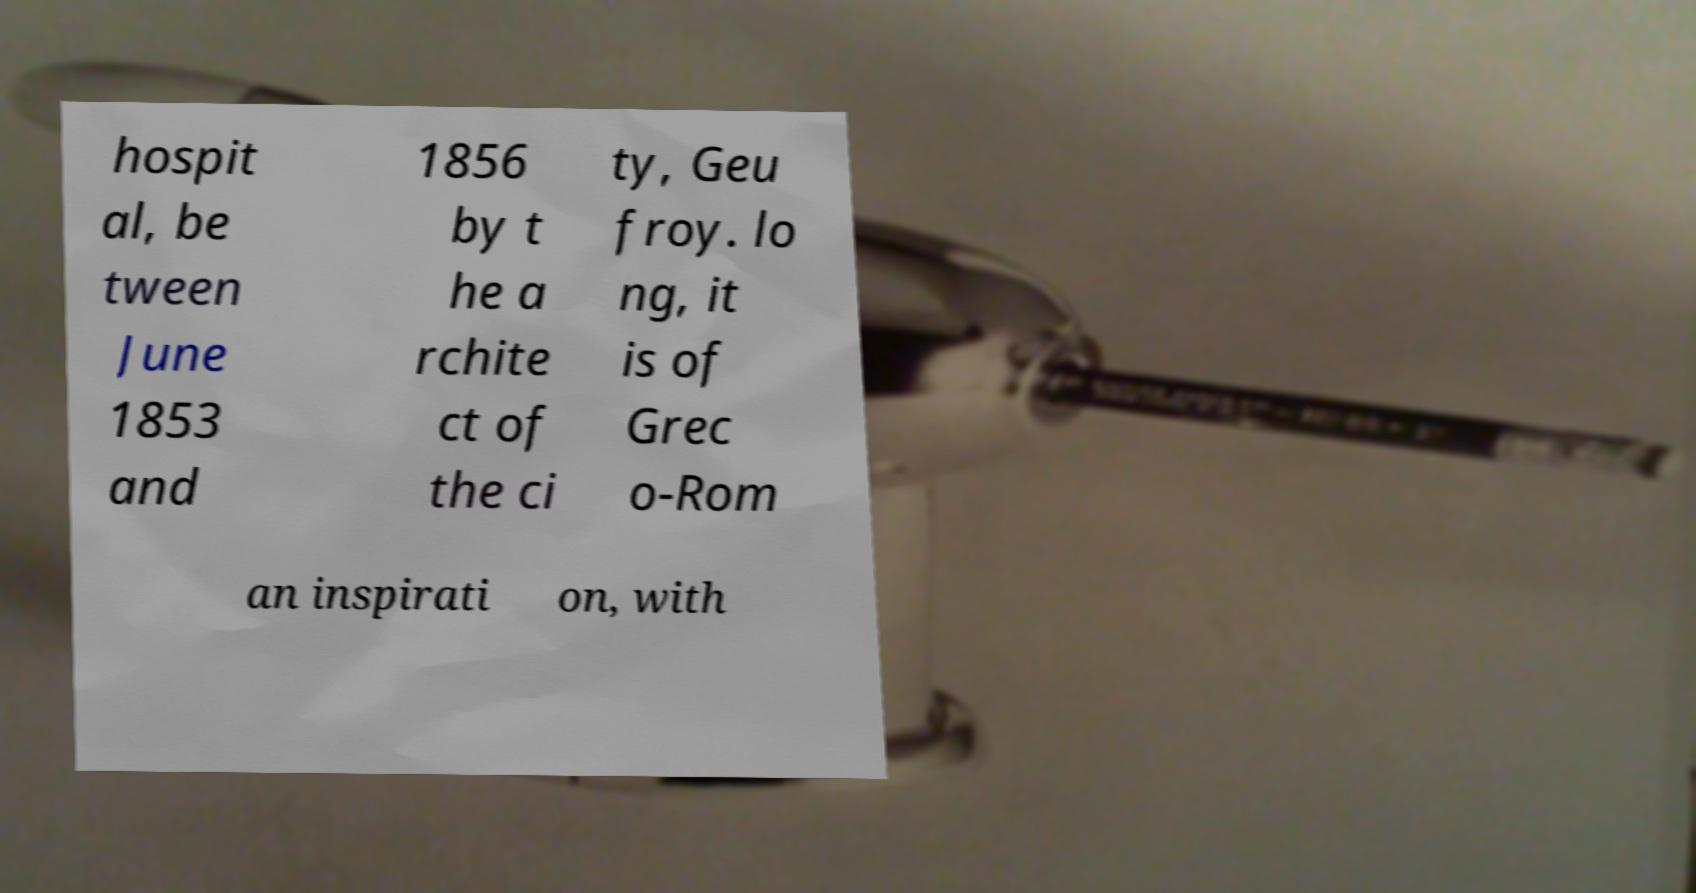Can you accurately transcribe the text from the provided image for me? hospit al, be tween June 1853 and 1856 by t he a rchite ct of the ci ty, Geu froy. lo ng, it is of Grec o-Rom an inspirati on, with 